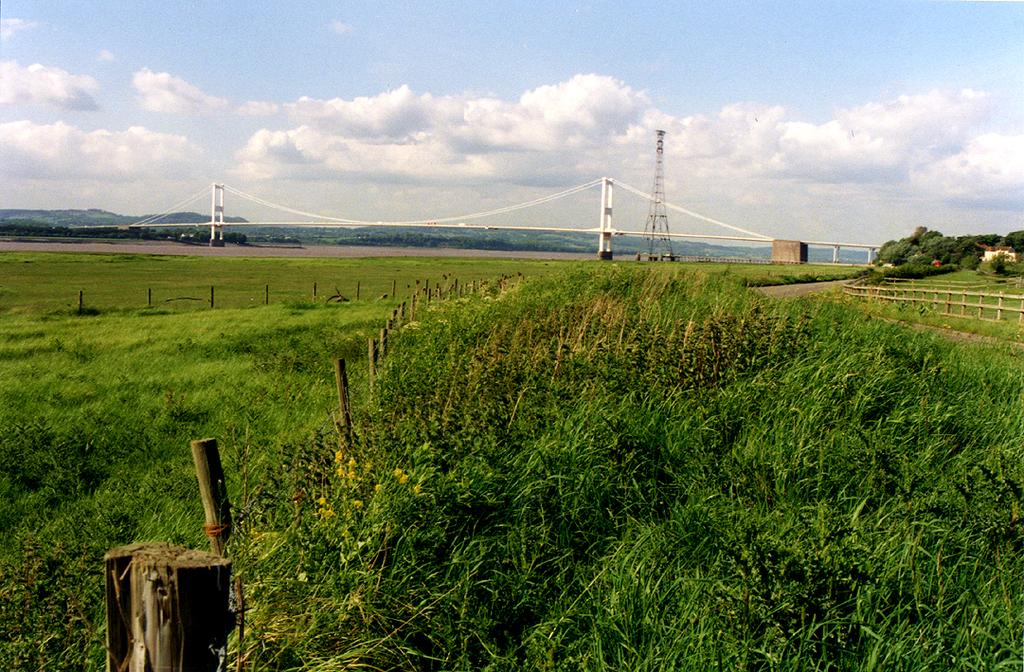What type of vegetation is present in the image? There are plants in the image. What man-made structure can be seen in the image? There is a bridge in the image. What tall structure is visible in the image? There is a tower in the image. What type of natural vegetation is present in the image? There are trees in the image. What can be seen in the sky in the image? Clouds are visible in the sky. What type of farm animals can be seen grazing on the fifth floor of the tower in the image? There is no farm or animals present in the image, and the tower does not have a fifth floor. 